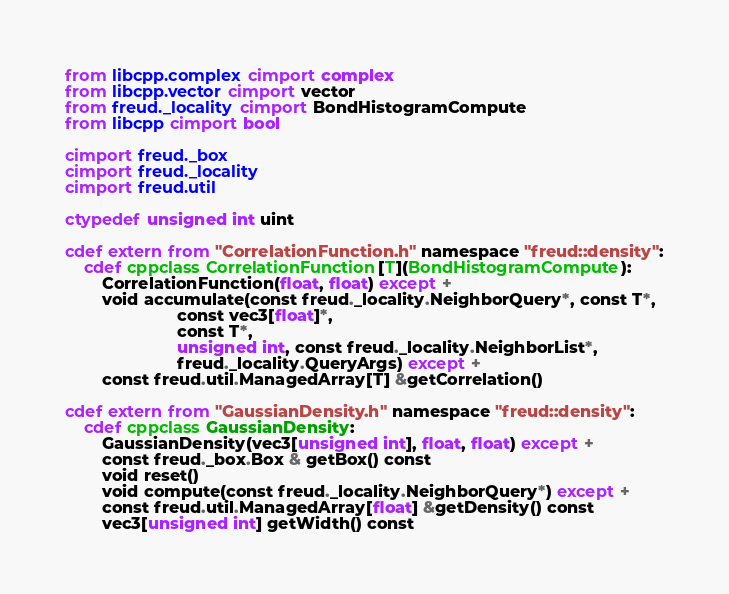<code> <loc_0><loc_0><loc_500><loc_500><_Cython_>from libcpp.complex cimport complex
from libcpp.vector cimport vector
from freud._locality cimport BondHistogramCompute
from libcpp cimport bool

cimport freud._box
cimport freud._locality
cimport freud.util

ctypedef unsigned int uint

cdef extern from "CorrelationFunction.h" namespace "freud::density":
    cdef cppclass CorrelationFunction[T](BondHistogramCompute):
        CorrelationFunction(float, float) except +
        void accumulate(const freud._locality.NeighborQuery*, const T*,
                        const vec3[float]*,
                        const T*,
                        unsigned int, const freud._locality.NeighborList*,
                        freud._locality.QueryArgs) except +
        const freud.util.ManagedArray[T] &getCorrelation()

cdef extern from "GaussianDensity.h" namespace "freud::density":
    cdef cppclass GaussianDensity:
        GaussianDensity(vec3[unsigned int], float, float) except +
        const freud._box.Box & getBox() const
        void reset()
        void compute(const freud._locality.NeighborQuery*) except +
        const freud.util.ManagedArray[float] &getDensity() const
        vec3[unsigned int] getWidth() const</code> 